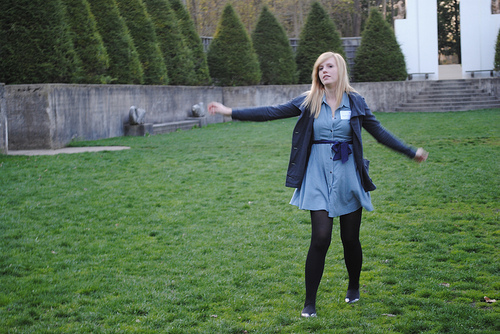<image>
Is there a woman in front of the tree? Yes. The woman is positioned in front of the tree, appearing closer to the camera viewpoint. 